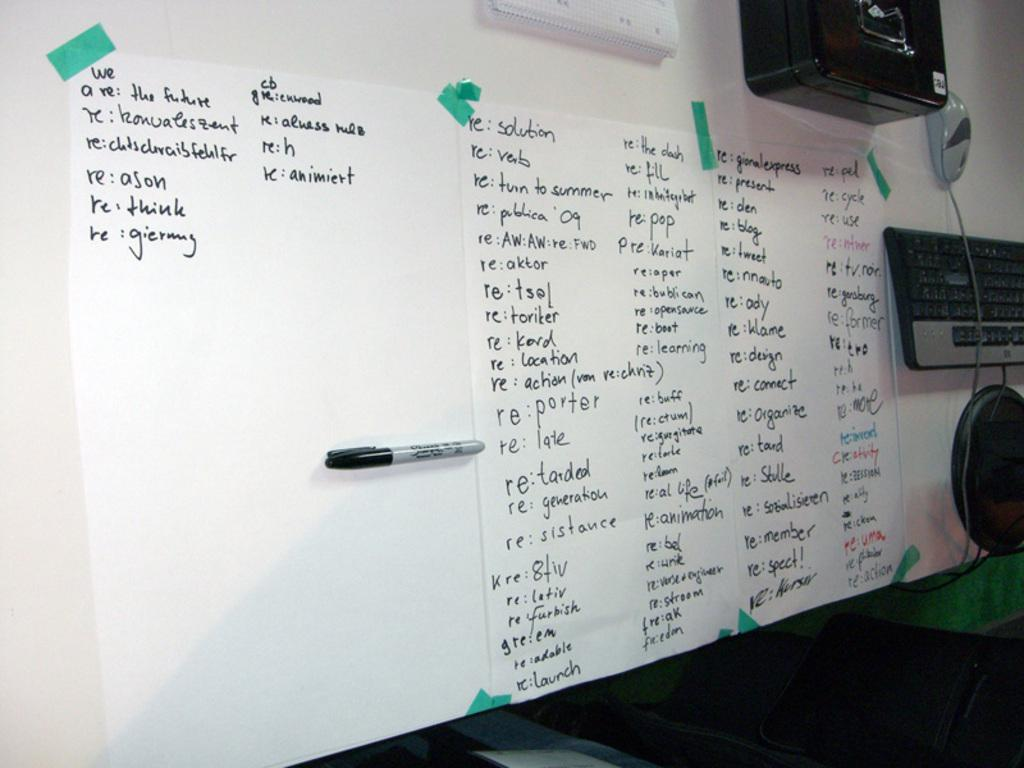<image>
Relay a brief, clear account of the picture shown. Whiteboard with words on it including a sentence saying "We Are the Future". 